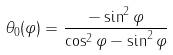Convert formula to latex. <formula><loc_0><loc_0><loc_500><loc_500>\theta _ { 0 } ( \varphi ) = \frac { - \sin ^ { 2 } \varphi } { \cos ^ { 2 } \varphi - \sin ^ { 2 } \varphi }</formula> 